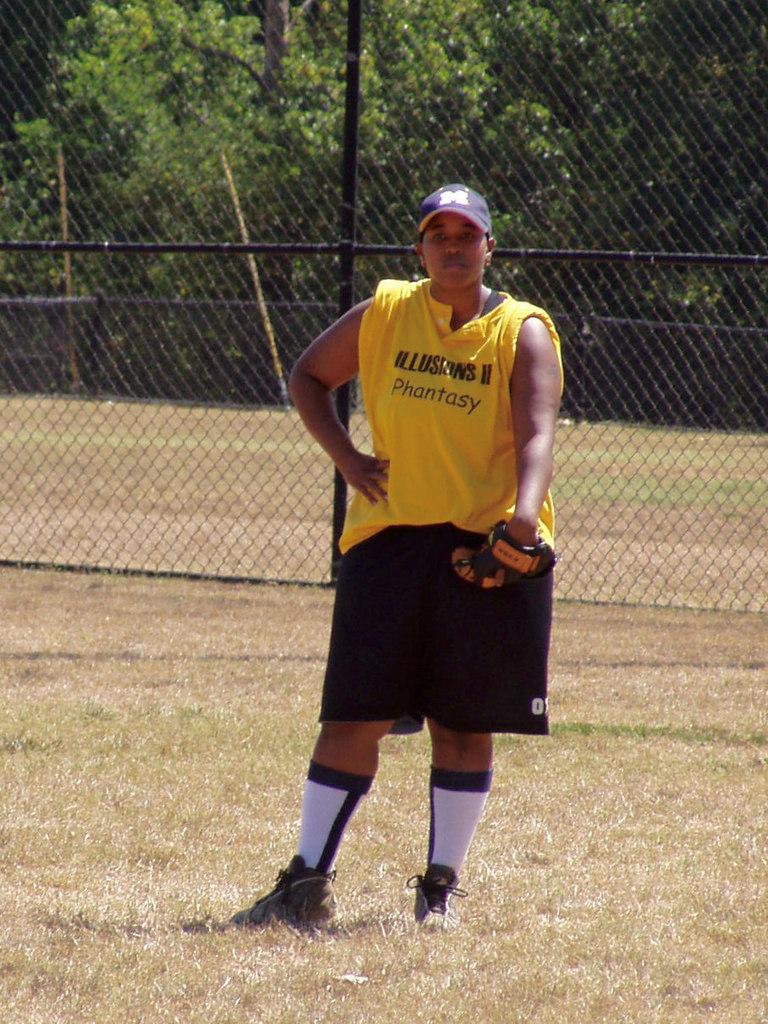What does her shirt say?
Keep it short and to the point. Illusions ii phantasy. What letter is on his hat?
Give a very brief answer. M. 